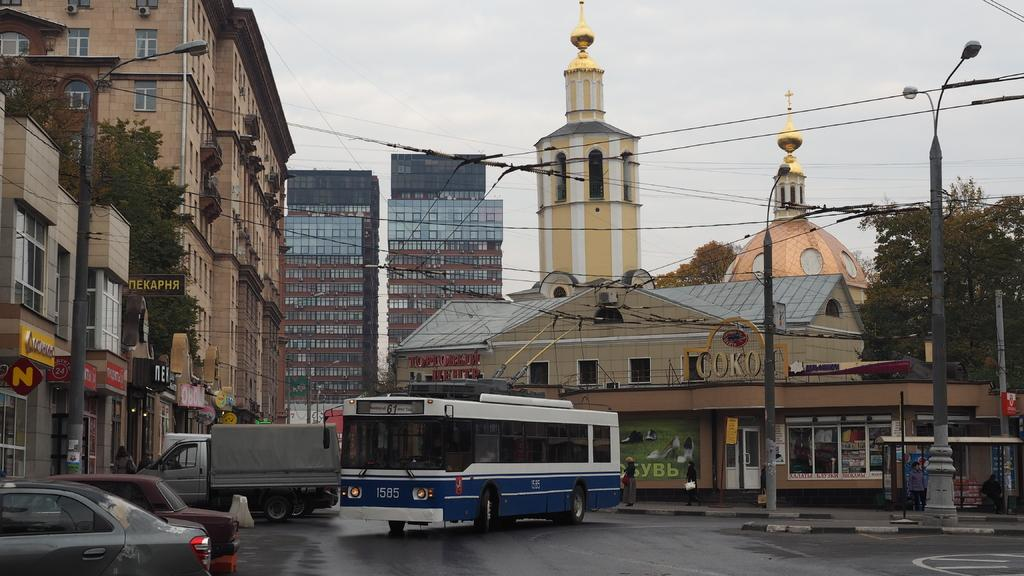What can be seen on the road in the image? There are vehicles on the road in the image. What structures are present in the image? There are poles, trees, buildings, and boards in the image. What type of illumination is visible in the image? There are lights in the image. What is visible in the background of the image? The sky is visible in the background of the image. Can you see a card being played on the hill in the image? There is no card or hill present in the image. What type of amusement can be seen in the image? There is no amusement depicted in the image; it features vehicles on the road, poles, trees, buildings, boards, lights, and the sky. 